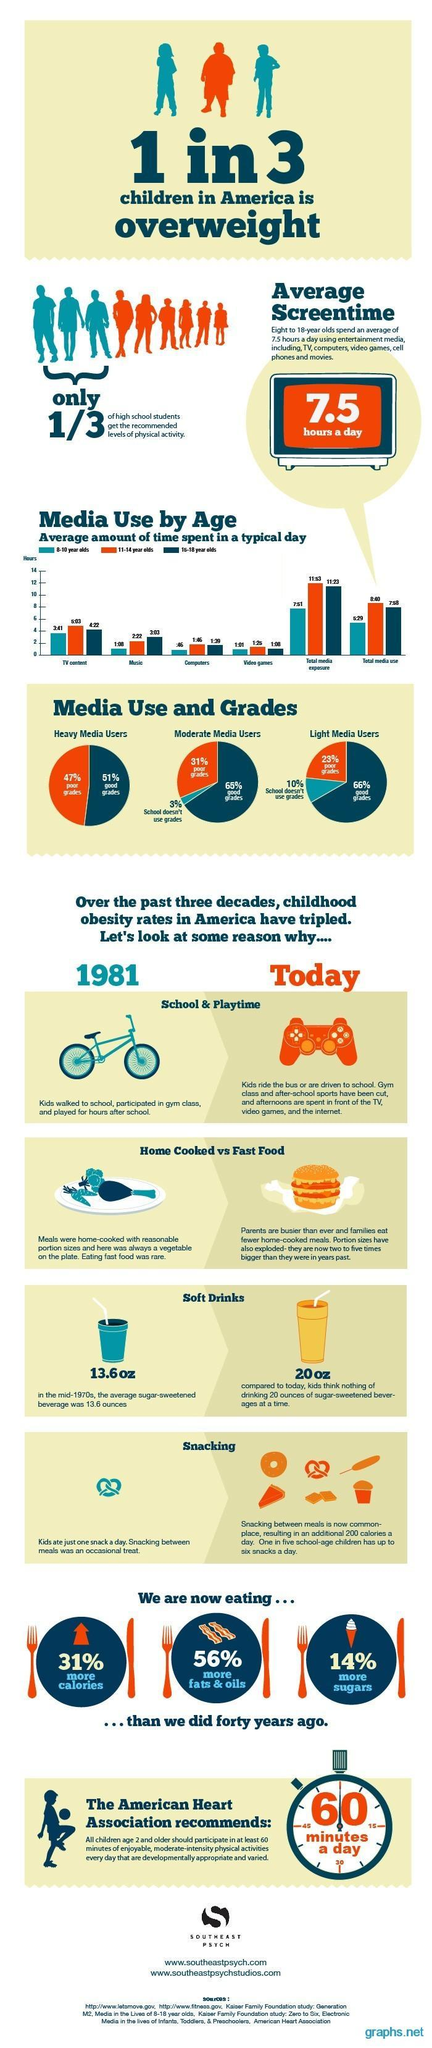What percentage of high school students get the recommended levels of physical activity?
Answer the question with a short phrase. 33.33% Which age group spends more time in TV content in children aged 8-18? 11-14 year olds What color represents good grades in the pie chart, blue, orange or green? blue What percentage of school-age children have up to six snacks a day? 20% How many hours on average a week do 8 to 18 year olds spend using entertainment media? 52.5 What color represents poor grades in the pie chart, blue, orange or green? orange Which age group spends more time in music in children aged 8-18? 16-18 year olds What percentage of children in America is overweight? 33.33% 